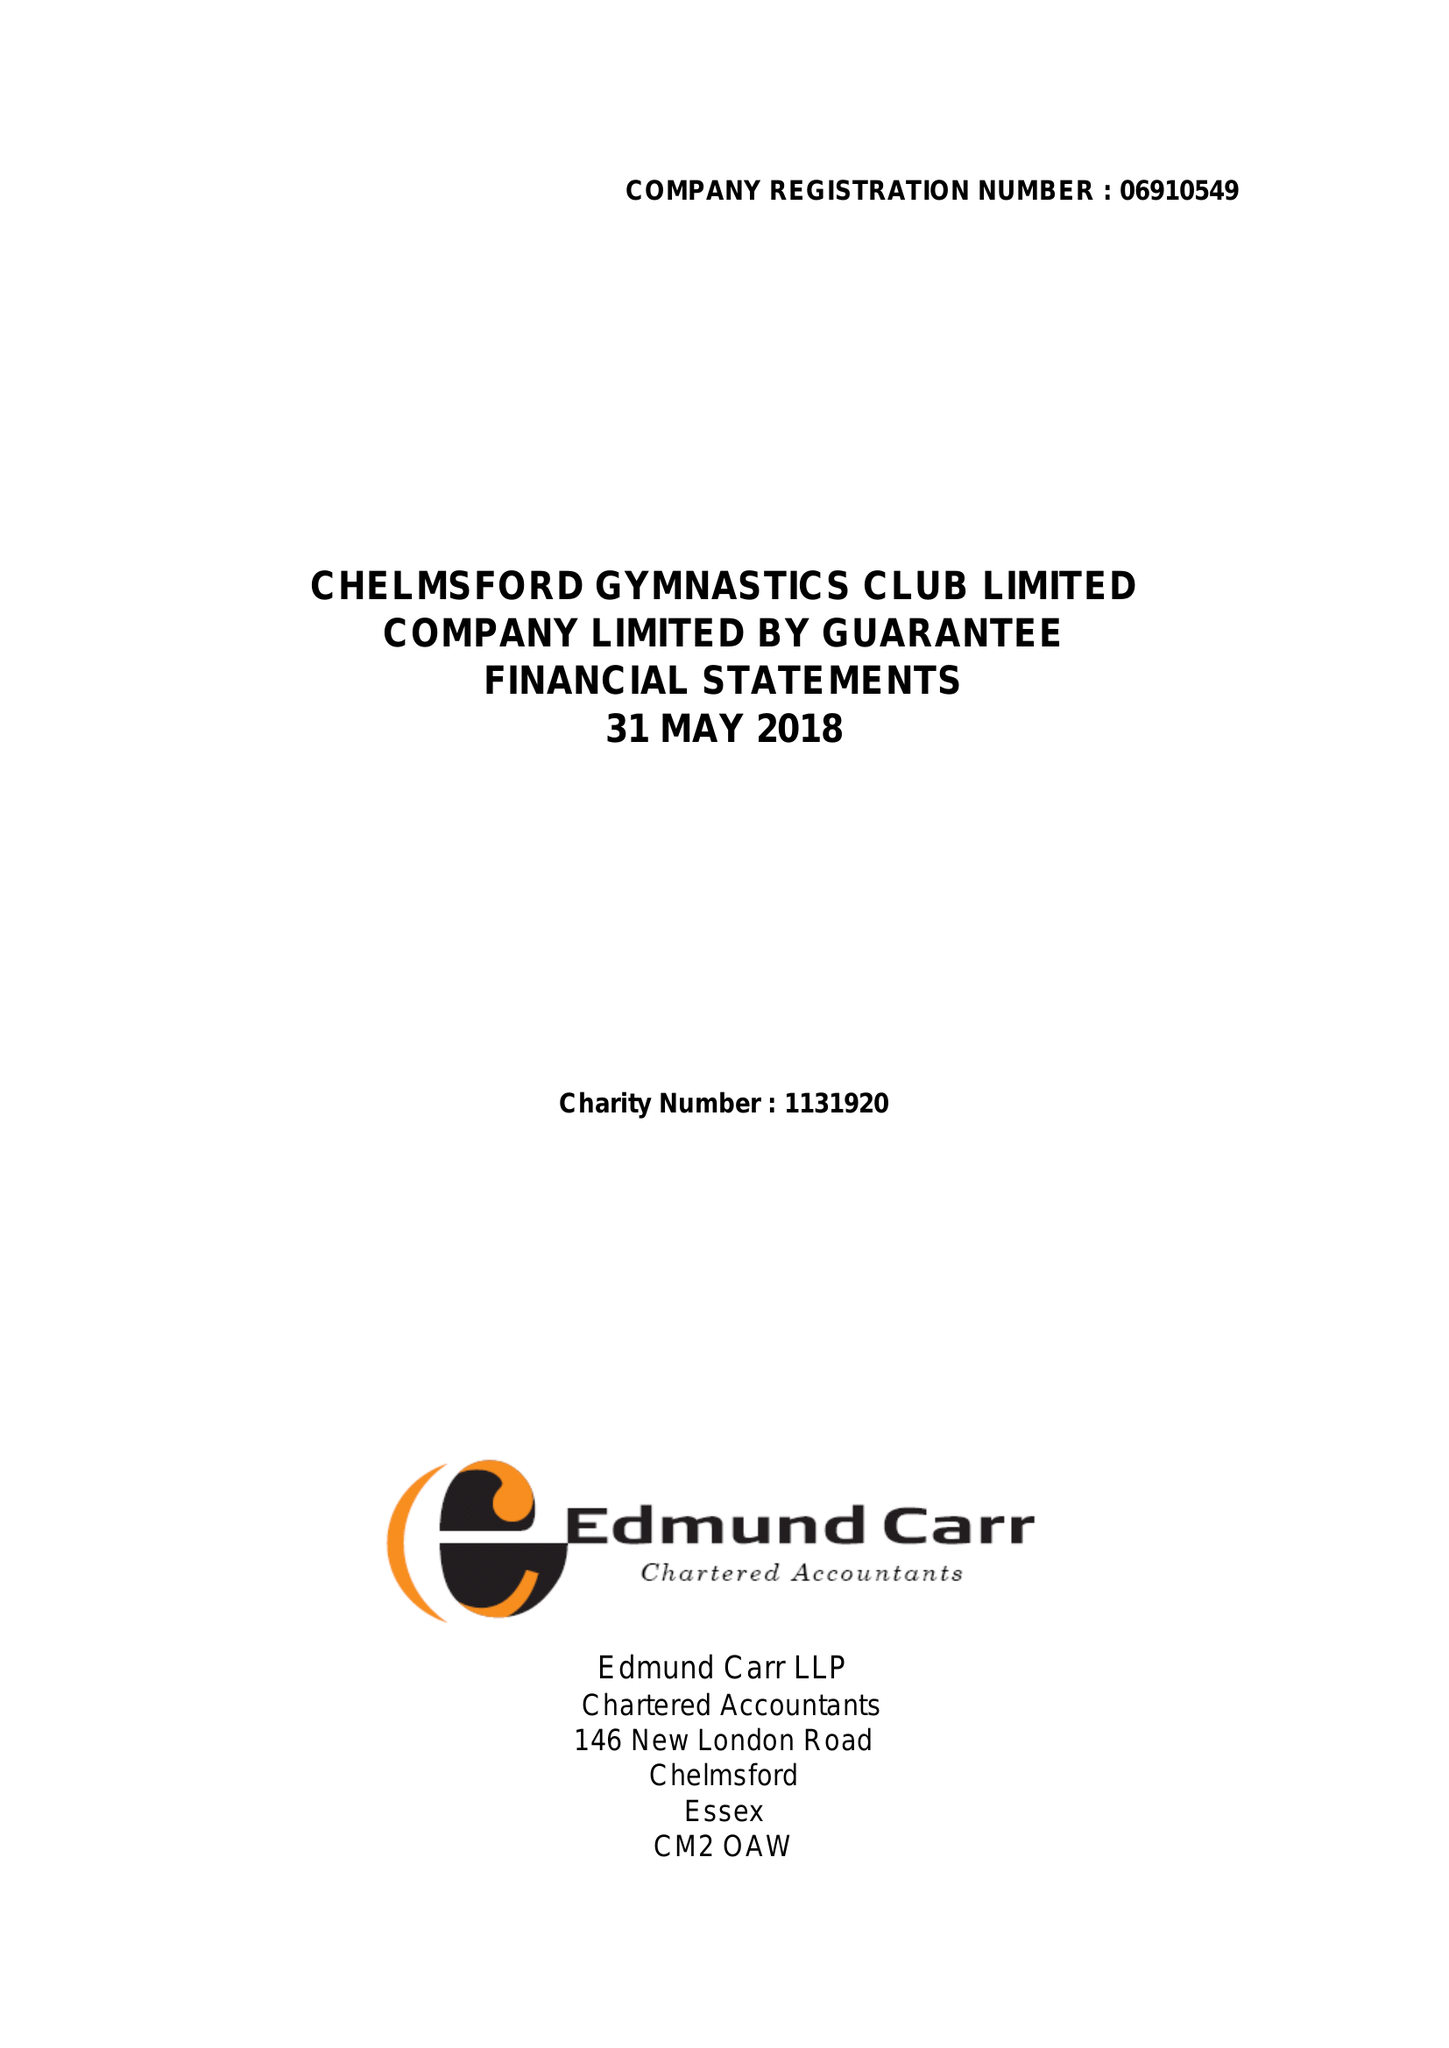What is the value for the address__street_line?
Answer the question using a single word or phrase. 9 THE HEYTHROP 